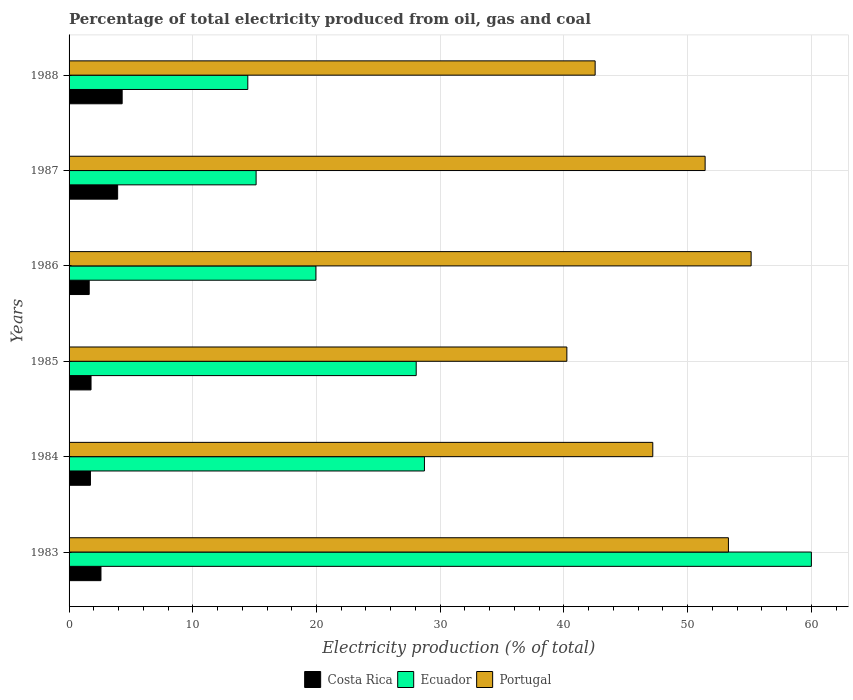How many different coloured bars are there?
Offer a very short reply. 3. How many groups of bars are there?
Provide a succinct answer. 6. What is the label of the 1st group of bars from the top?
Your answer should be compact. 1988. What is the electricity production in in Costa Rica in 1985?
Your answer should be very brief. 1.78. Across all years, what is the maximum electricity production in in Costa Rica?
Offer a terse response. 4.29. Across all years, what is the minimum electricity production in in Portugal?
Provide a succinct answer. 40.24. What is the total electricity production in in Costa Rica in the graph?
Your answer should be compact. 15.93. What is the difference between the electricity production in in Ecuador in 1984 and that in 1986?
Your response must be concise. 8.77. What is the difference between the electricity production in in Portugal in 1987 and the electricity production in in Ecuador in 1984?
Keep it short and to the point. 22.69. What is the average electricity production in in Ecuador per year?
Provide a short and direct response. 27.72. In the year 1987, what is the difference between the electricity production in in Portugal and electricity production in in Ecuador?
Make the answer very short. 36.3. What is the ratio of the electricity production in in Ecuador in 1983 to that in 1985?
Your answer should be compact. 2.14. What is the difference between the highest and the second highest electricity production in in Ecuador?
Make the answer very short. 31.28. What is the difference between the highest and the lowest electricity production in in Portugal?
Ensure brevity in your answer.  14.89. In how many years, is the electricity production in in Portugal greater than the average electricity production in in Portugal taken over all years?
Provide a short and direct response. 3. Is the sum of the electricity production in in Costa Rica in 1984 and 1988 greater than the maximum electricity production in in Portugal across all years?
Ensure brevity in your answer.  No. What does the 1st bar from the bottom in 1984 represents?
Make the answer very short. Costa Rica. How many bars are there?
Offer a very short reply. 18. Are all the bars in the graph horizontal?
Your response must be concise. Yes. How many years are there in the graph?
Make the answer very short. 6. Are the values on the major ticks of X-axis written in scientific E-notation?
Give a very brief answer. No. Does the graph contain any zero values?
Your answer should be very brief. No. Where does the legend appear in the graph?
Ensure brevity in your answer.  Bottom center. How are the legend labels stacked?
Your answer should be very brief. Horizontal. What is the title of the graph?
Your answer should be compact. Percentage of total electricity produced from oil, gas and coal. What is the label or title of the X-axis?
Keep it short and to the point. Electricity production (% of total). What is the label or title of the Y-axis?
Offer a terse response. Years. What is the Electricity production (% of total) of Costa Rica in 1983?
Your answer should be very brief. 2.58. What is the Electricity production (% of total) of Ecuador in 1983?
Your answer should be compact. 60. What is the Electricity production (% of total) of Portugal in 1983?
Ensure brevity in your answer.  53.3. What is the Electricity production (% of total) in Costa Rica in 1984?
Keep it short and to the point. 1.73. What is the Electricity production (% of total) of Ecuador in 1984?
Offer a very short reply. 28.73. What is the Electricity production (% of total) in Portugal in 1984?
Ensure brevity in your answer.  47.18. What is the Electricity production (% of total) in Costa Rica in 1985?
Your answer should be very brief. 1.78. What is the Electricity production (% of total) of Ecuador in 1985?
Your response must be concise. 28.06. What is the Electricity production (% of total) of Portugal in 1985?
Provide a short and direct response. 40.24. What is the Electricity production (% of total) in Costa Rica in 1986?
Keep it short and to the point. 1.63. What is the Electricity production (% of total) of Ecuador in 1986?
Your response must be concise. 19.95. What is the Electricity production (% of total) in Portugal in 1986?
Offer a terse response. 55.13. What is the Electricity production (% of total) in Costa Rica in 1987?
Your answer should be compact. 3.93. What is the Electricity production (% of total) of Ecuador in 1987?
Your answer should be compact. 15.12. What is the Electricity production (% of total) in Portugal in 1987?
Give a very brief answer. 51.42. What is the Electricity production (% of total) of Costa Rica in 1988?
Provide a succinct answer. 4.29. What is the Electricity production (% of total) of Ecuador in 1988?
Offer a terse response. 14.45. What is the Electricity production (% of total) of Portugal in 1988?
Your answer should be very brief. 42.52. Across all years, what is the maximum Electricity production (% of total) of Costa Rica?
Your response must be concise. 4.29. Across all years, what is the maximum Electricity production (% of total) in Ecuador?
Provide a short and direct response. 60. Across all years, what is the maximum Electricity production (% of total) in Portugal?
Give a very brief answer. 55.13. Across all years, what is the minimum Electricity production (% of total) in Costa Rica?
Provide a short and direct response. 1.63. Across all years, what is the minimum Electricity production (% of total) in Ecuador?
Give a very brief answer. 14.45. Across all years, what is the minimum Electricity production (% of total) of Portugal?
Provide a short and direct response. 40.24. What is the total Electricity production (% of total) in Costa Rica in the graph?
Offer a terse response. 15.93. What is the total Electricity production (% of total) in Ecuador in the graph?
Keep it short and to the point. 166.31. What is the total Electricity production (% of total) in Portugal in the graph?
Provide a succinct answer. 289.8. What is the difference between the Electricity production (% of total) of Costa Rica in 1983 and that in 1984?
Your answer should be compact. 0.85. What is the difference between the Electricity production (% of total) of Ecuador in 1983 and that in 1984?
Keep it short and to the point. 31.28. What is the difference between the Electricity production (% of total) of Portugal in 1983 and that in 1984?
Ensure brevity in your answer.  6.11. What is the difference between the Electricity production (% of total) of Costa Rica in 1983 and that in 1985?
Give a very brief answer. 0.8. What is the difference between the Electricity production (% of total) of Ecuador in 1983 and that in 1985?
Your response must be concise. 31.94. What is the difference between the Electricity production (% of total) in Portugal in 1983 and that in 1985?
Provide a short and direct response. 13.06. What is the difference between the Electricity production (% of total) in Costa Rica in 1983 and that in 1986?
Offer a terse response. 0.95. What is the difference between the Electricity production (% of total) of Ecuador in 1983 and that in 1986?
Make the answer very short. 40.05. What is the difference between the Electricity production (% of total) of Portugal in 1983 and that in 1986?
Provide a short and direct response. -1.83. What is the difference between the Electricity production (% of total) in Costa Rica in 1983 and that in 1987?
Keep it short and to the point. -1.35. What is the difference between the Electricity production (% of total) in Ecuador in 1983 and that in 1987?
Your answer should be compact. 44.89. What is the difference between the Electricity production (% of total) in Portugal in 1983 and that in 1987?
Offer a terse response. 1.88. What is the difference between the Electricity production (% of total) of Costa Rica in 1983 and that in 1988?
Offer a very short reply. -1.71. What is the difference between the Electricity production (% of total) of Ecuador in 1983 and that in 1988?
Give a very brief answer. 45.56. What is the difference between the Electricity production (% of total) in Portugal in 1983 and that in 1988?
Offer a terse response. 10.77. What is the difference between the Electricity production (% of total) in Costa Rica in 1984 and that in 1985?
Ensure brevity in your answer.  -0.05. What is the difference between the Electricity production (% of total) in Ecuador in 1984 and that in 1985?
Your response must be concise. 0.67. What is the difference between the Electricity production (% of total) in Portugal in 1984 and that in 1985?
Offer a terse response. 6.94. What is the difference between the Electricity production (% of total) of Costa Rica in 1984 and that in 1986?
Provide a short and direct response. 0.1. What is the difference between the Electricity production (% of total) in Ecuador in 1984 and that in 1986?
Provide a succinct answer. 8.77. What is the difference between the Electricity production (% of total) of Portugal in 1984 and that in 1986?
Provide a short and direct response. -7.95. What is the difference between the Electricity production (% of total) in Costa Rica in 1984 and that in 1987?
Give a very brief answer. -2.2. What is the difference between the Electricity production (% of total) in Ecuador in 1984 and that in 1987?
Your answer should be compact. 13.61. What is the difference between the Electricity production (% of total) of Portugal in 1984 and that in 1987?
Provide a succinct answer. -4.23. What is the difference between the Electricity production (% of total) of Costa Rica in 1984 and that in 1988?
Ensure brevity in your answer.  -2.56. What is the difference between the Electricity production (% of total) in Ecuador in 1984 and that in 1988?
Provide a succinct answer. 14.28. What is the difference between the Electricity production (% of total) in Portugal in 1984 and that in 1988?
Give a very brief answer. 4.66. What is the difference between the Electricity production (% of total) of Costa Rica in 1985 and that in 1986?
Keep it short and to the point. 0.15. What is the difference between the Electricity production (% of total) of Ecuador in 1985 and that in 1986?
Provide a succinct answer. 8.11. What is the difference between the Electricity production (% of total) of Portugal in 1985 and that in 1986?
Your response must be concise. -14.89. What is the difference between the Electricity production (% of total) in Costa Rica in 1985 and that in 1987?
Offer a very short reply. -2.15. What is the difference between the Electricity production (% of total) in Ecuador in 1985 and that in 1987?
Your answer should be compact. 12.94. What is the difference between the Electricity production (% of total) of Portugal in 1985 and that in 1987?
Give a very brief answer. -11.18. What is the difference between the Electricity production (% of total) in Costa Rica in 1985 and that in 1988?
Make the answer very short. -2.52. What is the difference between the Electricity production (% of total) in Ecuador in 1985 and that in 1988?
Offer a very short reply. 13.61. What is the difference between the Electricity production (% of total) in Portugal in 1985 and that in 1988?
Offer a terse response. -2.29. What is the difference between the Electricity production (% of total) in Costa Rica in 1986 and that in 1987?
Your answer should be compact. -2.3. What is the difference between the Electricity production (% of total) in Ecuador in 1986 and that in 1987?
Make the answer very short. 4.83. What is the difference between the Electricity production (% of total) of Portugal in 1986 and that in 1987?
Your answer should be very brief. 3.72. What is the difference between the Electricity production (% of total) of Costa Rica in 1986 and that in 1988?
Offer a very short reply. -2.66. What is the difference between the Electricity production (% of total) in Ecuador in 1986 and that in 1988?
Your answer should be very brief. 5.5. What is the difference between the Electricity production (% of total) in Portugal in 1986 and that in 1988?
Make the answer very short. 12.61. What is the difference between the Electricity production (% of total) of Costa Rica in 1987 and that in 1988?
Your answer should be compact. -0.36. What is the difference between the Electricity production (% of total) of Ecuador in 1987 and that in 1988?
Offer a terse response. 0.67. What is the difference between the Electricity production (% of total) of Portugal in 1987 and that in 1988?
Ensure brevity in your answer.  8.89. What is the difference between the Electricity production (% of total) in Costa Rica in 1983 and the Electricity production (% of total) in Ecuador in 1984?
Provide a short and direct response. -26.15. What is the difference between the Electricity production (% of total) in Costa Rica in 1983 and the Electricity production (% of total) in Portugal in 1984?
Provide a short and direct response. -44.61. What is the difference between the Electricity production (% of total) of Ecuador in 1983 and the Electricity production (% of total) of Portugal in 1984?
Your response must be concise. 12.82. What is the difference between the Electricity production (% of total) of Costa Rica in 1983 and the Electricity production (% of total) of Ecuador in 1985?
Offer a very short reply. -25.48. What is the difference between the Electricity production (% of total) of Costa Rica in 1983 and the Electricity production (% of total) of Portugal in 1985?
Your response must be concise. -37.66. What is the difference between the Electricity production (% of total) in Ecuador in 1983 and the Electricity production (% of total) in Portugal in 1985?
Make the answer very short. 19.77. What is the difference between the Electricity production (% of total) in Costa Rica in 1983 and the Electricity production (% of total) in Ecuador in 1986?
Offer a very short reply. -17.37. What is the difference between the Electricity production (% of total) in Costa Rica in 1983 and the Electricity production (% of total) in Portugal in 1986?
Offer a very short reply. -52.56. What is the difference between the Electricity production (% of total) in Ecuador in 1983 and the Electricity production (% of total) in Portugal in 1986?
Ensure brevity in your answer.  4.87. What is the difference between the Electricity production (% of total) in Costa Rica in 1983 and the Electricity production (% of total) in Ecuador in 1987?
Make the answer very short. -12.54. What is the difference between the Electricity production (% of total) of Costa Rica in 1983 and the Electricity production (% of total) of Portugal in 1987?
Provide a short and direct response. -48.84. What is the difference between the Electricity production (% of total) in Ecuador in 1983 and the Electricity production (% of total) in Portugal in 1987?
Ensure brevity in your answer.  8.59. What is the difference between the Electricity production (% of total) in Costa Rica in 1983 and the Electricity production (% of total) in Ecuador in 1988?
Your response must be concise. -11.87. What is the difference between the Electricity production (% of total) in Costa Rica in 1983 and the Electricity production (% of total) in Portugal in 1988?
Provide a succinct answer. -39.95. What is the difference between the Electricity production (% of total) in Ecuador in 1983 and the Electricity production (% of total) in Portugal in 1988?
Keep it short and to the point. 17.48. What is the difference between the Electricity production (% of total) of Costa Rica in 1984 and the Electricity production (% of total) of Ecuador in 1985?
Your answer should be compact. -26.33. What is the difference between the Electricity production (% of total) in Costa Rica in 1984 and the Electricity production (% of total) in Portugal in 1985?
Give a very brief answer. -38.51. What is the difference between the Electricity production (% of total) in Ecuador in 1984 and the Electricity production (% of total) in Portugal in 1985?
Make the answer very short. -11.51. What is the difference between the Electricity production (% of total) of Costa Rica in 1984 and the Electricity production (% of total) of Ecuador in 1986?
Your answer should be very brief. -18.22. What is the difference between the Electricity production (% of total) of Costa Rica in 1984 and the Electricity production (% of total) of Portugal in 1986?
Your answer should be compact. -53.41. What is the difference between the Electricity production (% of total) of Ecuador in 1984 and the Electricity production (% of total) of Portugal in 1986?
Give a very brief answer. -26.41. What is the difference between the Electricity production (% of total) of Costa Rica in 1984 and the Electricity production (% of total) of Ecuador in 1987?
Provide a succinct answer. -13.39. What is the difference between the Electricity production (% of total) in Costa Rica in 1984 and the Electricity production (% of total) in Portugal in 1987?
Make the answer very short. -49.69. What is the difference between the Electricity production (% of total) of Ecuador in 1984 and the Electricity production (% of total) of Portugal in 1987?
Your response must be concise. -22.69. What is the difference between the Electricity production (% of total) of Costa Rica in 1984 and the Electricity production (% of total) of Ecuador in 1988?
Make the answer very short. -12.72. What is the difference between the Electricity production (% of total) in Costa Rica in 1984 and the Electricity production (% of total) in Portugal in 1988?
Your answer should be compact. -40.8. What is the difference between the Electricity production (% of total) of Ecuador in 1984 and the Electricity production (% of total) of Portugal in 1988?
Your response must be concise. -13.8. What is the difference between the Electricity production (% of total) of Costa Rica in 1985 and the Electricity production (% of total) of Ecuador in 1986?
Make the answer very short. -18.18. What is the difference between the Electricity production (% of total) of Costa Rica in 1985 and the Electricity production (% of total) of Portugal in 1986?
Ensure brevity in your answer.  -53.36. What is the difference between the Electricity production (% of total) of Ecuador in 1985 and the Electricity production (% of total) of Portugal in 1986?
Your answer should be compact. -27.07. What is the difference between the Electricity production (% of total) in Costa Rica in 1985 and the Electricity production (% of total) in Ecuador in 1987?
Offer a terse response. -13.34. What is the difference between the Electricity production (% of total) of Costa Rica in 1985 and the Electricity production (% of total) of Portugal in 1987?
Give a very brief answer. -49.64. What is the difference between the Electricity production (% of total) of Ecuador in 1985 and the Electricity production (% of total) of Portugal in 1987?
Provide a short and direct response. -23.35. What is the difference between the Electricity production (% of total) of Costa Rica in 1985 and the Electricity production (% of total) of Ecuador in 1988?
Ensure brevity in your answer.  -12.67. What is the difference between the Electricity production (% of total) in Costa Rica in 1985 and the Electricity production (% of total) in Portugal in 1988?
Keep it short and to the point. -40.75. What is the difference between the Electricity production (% of total) in Ecuador in 1985 and the Electricity production (% of total) in Portugal in 1988?
Offer a terse response. -14.46. What is the difference between the Electricity production (% of total) of Costa Rica in 1986 and the Electricity production (% of total) of Ecuador in 1987?
Ensure brevity in your answer.  -13.49. What is the difference between the Electricity production (% of total) of Costa Rica in 1986 and the Electricity production (% of total) of Portugal in 1987?
Keep it short and to the point. -49.79. What is the difference between the Electricity production (% of total) of Ecuador in 1986 and the Electricity production (% of total) of Portugal in 1987?
Offer a very short reply. -31.46. What is the difference between the Electricity production (% of total) of Costa Rica in 1986 and the Electricity production (% of total) of Ecuador in 1988?
Give a very brief answer. -12.82. What is the difference between the Electricity production (% of total) of Costa Rica in 1986 and the Electricity production (% of total) of Portugal in 1988?
Make the answer very short. -40.9. What is the difference between the Electricity production (% of total) in Ecuador in 1986 and the Electricity production (% of total) in Portugal in 1988?
Your response must be concise. -22.57. What is the difference between the Electricity production (% of total) of Costa Rica in 1987 and the Electricity production (% of total) of Ecuador in 1988?
Give a very brief answer. -10.52. What is the difference between the Electricity production (% of total) of Costa Rica in 1987 and the Electricity production (% of total) of Portugal in 1988?
Ensure brevity in your answer.  -38.6. What is the difference between the Electricity production (% of total) in Ecuador in 1987 and the Electricity production (% of total) in Portugal in 1988?
Provide a short and direct response. -27.41. What is the average Electricity production (% of total) of Costa Rica per year?
Offer a terse response. 2.65. What is the average Electricity production (% of total) of Ecuador per year?
Offer a very short reply. 27.72. What is the average Electricity production (% of total) in Portugal per year?
Make the answer very short. 48.3. In the year 1983, what is the difference between the Electricity production (% of total) of Costa Rica and Electricity production (% of total) of Ecuador?
Provide a short and direct response. -57.43. In the year 1983, what is the difference between the Electricity production (% of total) in Costa Rica and Electricity production (% of total) in Portugal?
Offer a terse response. -50.72. In the year 1983, what is the difference between the Electricity production (% of total) of Ecuador and Electricity production (% of total) of Portugal?
Offer a very short reply. 6.71. In the year 1984, what is the difference between the Electricity production (% of total) in Costa Rica and Electricity production (% of total) in Ecuador?
Ensure brevity in your answer.  -27. In the year 1984, what is the difference between the Electricity production (% of total) of Costa Rica and Electricity production (% of total) of Portugal?
Provide a succinct answer. -45.46. In the year 1984, what is the difference between the Electricity production (% of total) in Ecuador and Electricity production (% of total) in Portugal?
Your response must be concise. -18.46. In the year 1985, what is the difference between the Electricity production (% of total) of Costa Rica and Electricity production (% of total) of Ecuador?
Give a very brief answer. -26.29. In the year 1985, what is the difference between the Electricity production (% of total) of Costa Rica and Electricity production (% of total) of Portugal?
Provide a short and direct response. -38.46. In the year 1985, what is the difference between the Electricity production (% of total) in Ecuador and Electricity production (% of total) in Portugal?
Keep it short and to the point. -12.18. In the year 1986, what is the difference between the Electricity production (% of total) in Costa Rica and Electricity production (% of total) in Ecuador?
Offer a very short reply. -18.32. In the year 1986, what is the difference between the Electricity production (% of total) of Costa Rica and Electricity production (% of total) of Portugal?
Give a very brief answer. -53.51. In the year 1986, what is the difference between the Electricity production (% of total) of Ecuador and Electricity production (% of total) of Portugal?
Ensure brevity in your answer.  -35.18. In the year 1987, what is the difference between the Electricity production (% of total) of Costa Rica and Electricity production (% of total) of Ecuador?
Your answer should be compact. -11.19. In the year 1987, what is the difference between the Electricity production (% of total) in Costa Rica and Electricity production (% of total) in Portugal?
Offer a very short reply. -47.49. In the year 1987, what is the difference between the Electricity production (% of total) of Ecuador and Electricity production (% of total) of Portugal?
Your response must be concise. -36.3. In the year 1988, what is the difference between the Electricity production (% of total) of Costa Rica and Electricity production (% of total) of Ecuador?
Give a very brief answer. -10.16. In the year 1988, what is the difference between the Electricity production (% of total) of Costa Rica and Electricity production (% of total) of Portugal?
Your answer should be very brief. -38.23. In the year 1988, what is the difference between the Electricity production (% of total) of Ecuador and Electricity production (% of total) of Portugal?
Provide a succinct answer. -28.08. What is the ratio of the Electricity production (% of total) in Costa Rica in 1983 to that in 1984?
Your response must be concise. 1.49. What is the ratio of the Electricity production (% of total) in Ecuador in 1983 to that in 1984?
Give a very brief answer. 2.09. What is the ratio of the Electricity production (% of total) of Portugal in 1983 to that in 1984?
Keep it short and to the point. 1.13. What is the ratio of the Electricity production (% of total) in Costa Rica in 1983 to that in 1985?
Provide a short and direct response. 1.45. What is the ratio of the Electricity production (% of total) of Ecuador in 1983 to that in 1985?
Offer a very short reply. 2.14. What is the ratio of the Electricity production (% of total) of Portugal in 1983 to that in 1985?
Your response must be concise. 1.32. What is the ratio of the Electricity production (% of total) of Costa Rica in 1983 to that in 1986?
Give a very brief answer. 1.58. What is the ratio of the Electricity production (% of total) of Ecuador in 1983 to that in 1986?
Your response must be concise. 3.01. What is the ratio of the Electricity production (% of total) of Portugal in 1983 to that in 1986?
Provide a short and direct response. 0.97. What is the ratio of the Electricity production (% of total) of Costa Rica in 1983 to that in 1987?
Your answer should be compact. 0.66. What is the ratio of the Electricity production (% of total) in Ecuador in 1983 to that in 1987?
Make the answer very short. 3.97. What is the ratio of the Electricity production (% of total) in Portugal in 1983 to that in 1987?
Your answer should be compact. 1.04. What is the ratio of the Electricity production (% of total) of Costa Rica in 1983 to that in 1988?
Your response must be concise. 0.6. What is the ratio of the Electricity production (% of total) in Ecuador in 1983 to that in 1988?
Provide a succinct answer. 4.15. What is the ratio of the Electricity production (% of total) of Portugal in 1983 to that in 1988?
Provide a succinct answer. 1.25. What is the ratio of the Electricity production (% of total) in Costa Rica in 1984 to that in 1985?
Make the answer very short. 0.97. What is the ratio of the Electricity production (% of total) in Ecuador in 1984 to that in 1985?
Give a very brief answer. 1.02. What is the ratio of the Electricity production (% of total) of Portugal in 1984 to that in 1985?
Offer a terse response. 1.17. What is the ratio of the Electricity production (% of total) of Costa Rica in 1984 to that in 1986?
Your answer should be compact. 1.06. What is the ratio of the Electricity production (% of total) of Ecuador in 1984 to that in 1986?
Offer a very short reply. 1.44. What is the ratio of the Electricity production (% of total) of Portugal in 1984 to that in 1986?
Keep it short and to the point. 0.86. What is the ratio of the Electricity production (% of total) in Costa Rica in 1984 to that in 1987?
Provide a succinct answer. 0.44. What is the ratio of the Electricity production (% of total) in Portugal in 1984 to that in 1987?
Offer a very short reply. 0.92. What is the ratio of the Electricity production (% of total) in Costa Rica in 1984 to that in 1988?
Ensure brevity in your answer.  0.4. What is the ratio of the Electricity production (% of total) of Ecuador in 1984 to that in 1988?
Make the answer very short. 1.99. What is the ratio of the Electricity production (% of total) in Portugal in 1984 to that in 1988?
Offer a very short reply. 1.11. What is the ratio of the Electricity production (% of total) in Ecuador in 1985 to that in 1986?
Offer a very short reply. 1.41. What is the ratio of the Electricity production (% of total) in Portugal in 1985 to that in 1986?
Your answer should be compact. 0.73. What is the ratio of the Electricity production (% of total) in Costa Rica in 1985 to that in 1987?
Ensure brevity in your answer.  0.45. What is the ratio of the Electricity production (% of total) of Ecuador in 1985 to that in 1987?
Provide a succinct answer. 1.86. What is the ratio of the Electricity production (% of total) in Portugal in 1985 to that in 1987?
Make the answer very short. 0.78. What is the ratio of the Electricity production (% of total) in Costa Rica in 1985 to that in 1988?
Offer a terse response. 0.41. What is the ratio of the Electricity production (% of total) of Ecuador in 1985 to that in 1988?
Your answer should be compact. 1.94. What is the ratio of the Electricity production (% of total) of Portugal in 1985 to that in 1988?
Provide a succinct answer. 0.95. What is the ratio of the Electricity production (% of total) of Costa Rica in 1986 to that in 1987?
Keep it short and to the point. 0.41. What is the ratio of the Electricity production (% of total) of Ecuador in 1986 to that in 1987?
Your response must be concise. 1.32. What is the ratio of the Electricity production (% of total) of Portugal in 1986 to that in 1987?
Your answer should be very brief. 1.07. What is the ratio of the Electricity production (% of total) of Costa Rica in 1986 to that in 1988?
Offer a very short reply. 0.38. What is the ratio of the Electricity production (% of total) in Ecuador in 1986 to that in 1988?
Offer a very short reply. 1.38. What is the ratio of the Electricity production (% of total) in Portugal in 1986 to that in 1988?
Make the answer very short. 1.3. What is the ratio of the Electricity production (% of total) in Costa Rica in 1987 to that in 1988?
Give a very brief answer. 0.92. What is the ratio of the Electricity production (% of total) of Ecuador in 1987 to that in 1988?
Make the answer very short. 1.05. What is the ratio of the Electricity production (% of total) in Portugal in 1987 to that in 1988?
Your answer should be very brief. 1.21. What is the difference between the highest and the second highest Electricity production (% of total) in Costa Rica?
Provide a succinct answer. 0.36. What is the difference between the highest and the second highest Electricity production (% of total) in Ecuador?
Your answer should be compact. 31.28. What is the difference between the highest and the second highest Electricity production (% of total) of Portugal?
Give a very brief answer. 1.83. What is the difference between the highest and the lowest Electricity production (% of total) of Costa Rica?
Offer a terse response. 2.66. What is the difference between the highest and the lowest Electricity production (% of total) in Ecuador?
Provide a succinct answer. 45.56. What is the difference between the highest and the lowest Electricity production (% of total) in Portugal?
Your response must be concise. 14.89. 